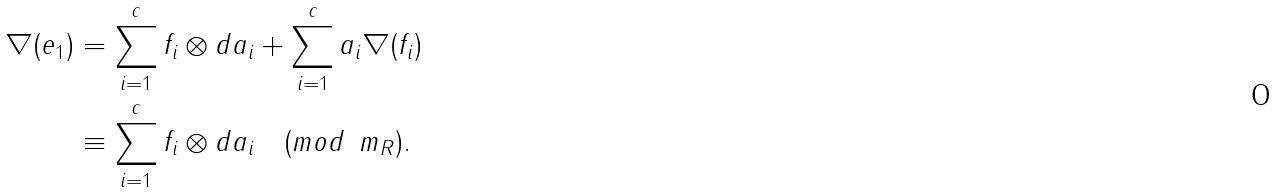<formula> <loc_0><loc_0><loc_500><loc_500>\nabla ( e _ { 1 } ) & = \sum _ { i = 1 } ^ { c } f _ { i } \otimes d a _ { i } + \sum _ { i = 1 } ^ { c } a _ { i } \nabla ( f _ { i } ) \\ & \equiv \sum _ { i = 1 } ^ { c } f _ { i } \otimes d a _ { i } \quad ( m o d \, \ m _ { R } ) .</formula> 